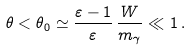Convert formula to latex. <formula><loc_0><loc_0><loc_500><loc_500>\theta < \theta _ { 0 } \simeq \frac { \varepsilon - 1 } { \varepsilon } \, \frac { W } { m _ { \gamma } } \ll 1 \, .</formula> 